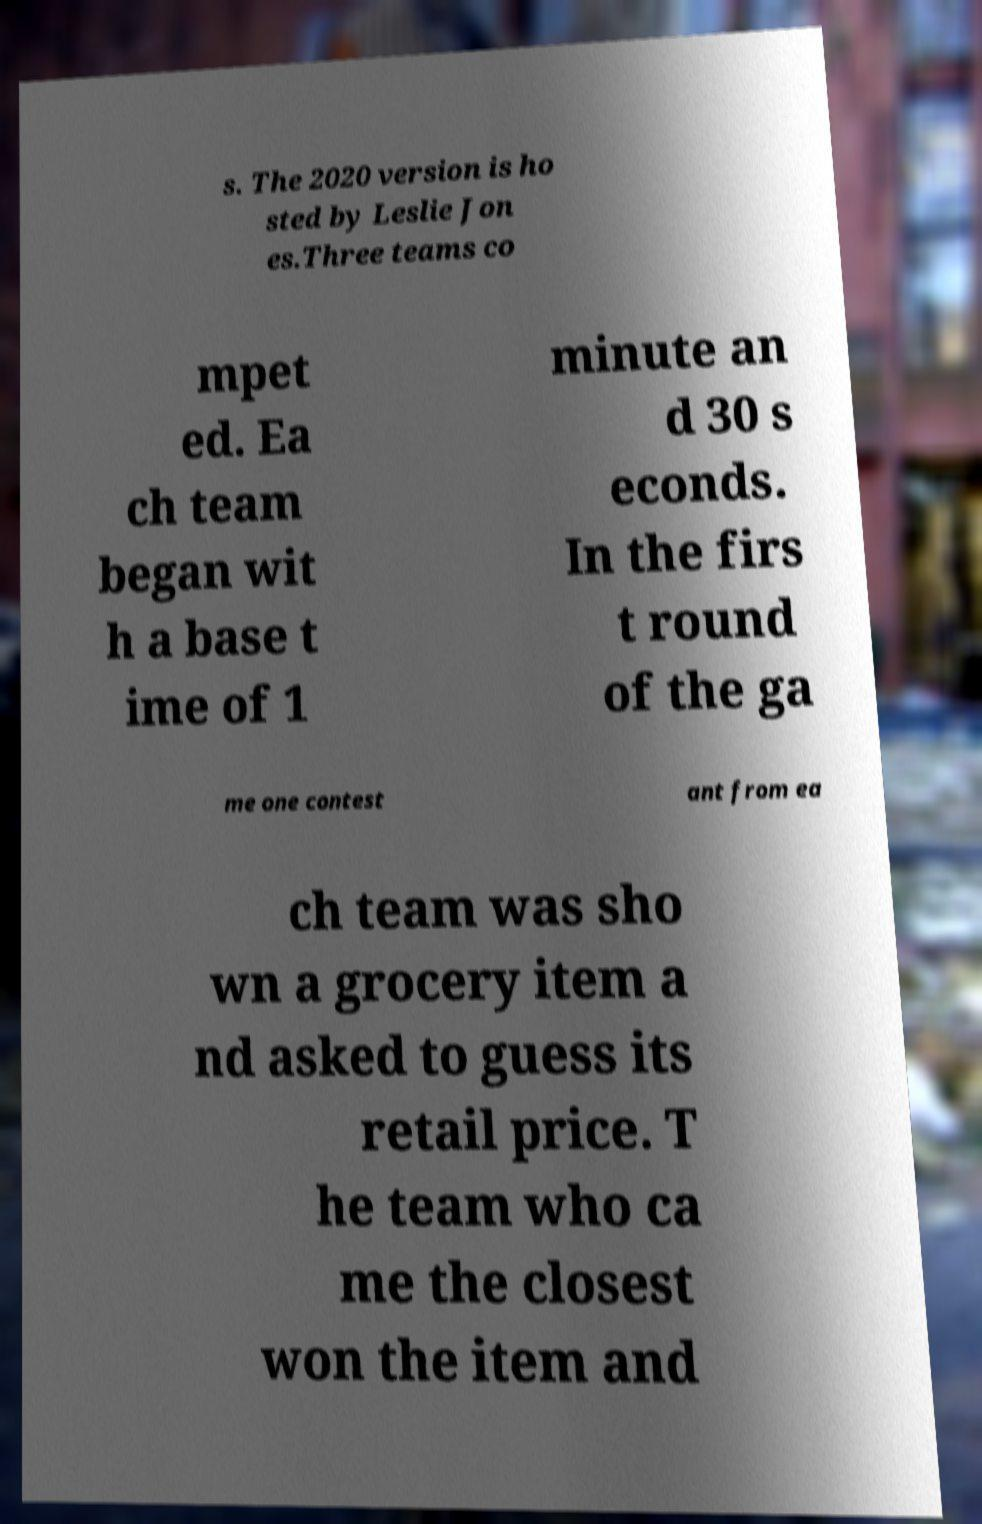Can you read and provide the text displayed in the image?This photo seems to have some interesting text. Can you extract and type it out for me? s. The 2020 version is ho sted by Leslie Jon es.Three teams co mpet ed. Ea ch team began wit h a base t ime of 1 minute an d 30 s econds. In the firs t round of the ga me one contest ant from ea ch team was sho wn a grocery item a nd asked to guess its retail price. T he team who ca me the closest won the item and 